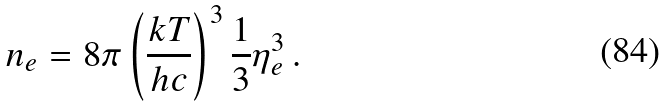<formula> <loc_0><loc_0><loc_500><loc_500>n _ { e } = 8 \pi \left ( \frac { k T } { h c } \right ) ^ { 3 } \frac { 1 } { 3 } \eta _ { e } ^ { 3 } \, .</formula> 